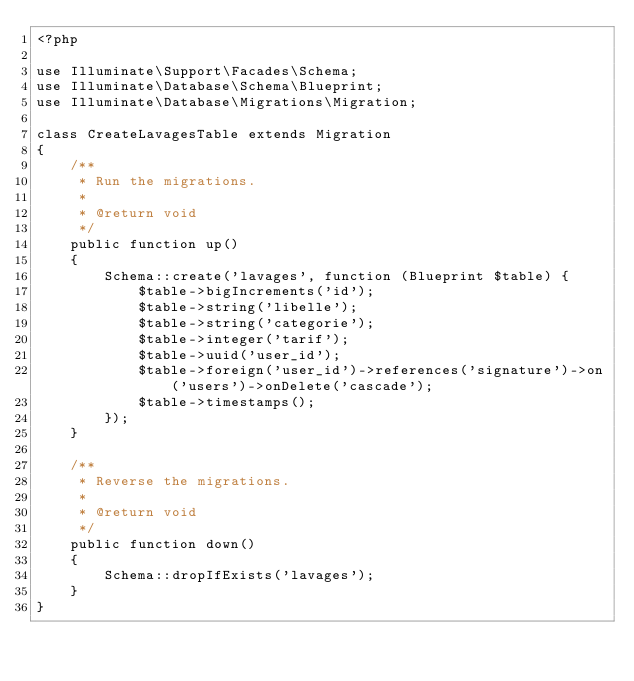<code> <loc_0><loc_0><loc_500><loc_500><_PHP_><?php

use Illuminate\Support\Facades\Schema;
use Illuminate\Database\Schema\Blueprint;
use Illuminate\Database\Migrations\Migration;

class CreateLavagesTable extends Migration
{
    /**
     * Run the migrations.
     *
     * @return void
     */
    public function up()
    {
        Schema::create('lavages', function (Blueprint $table) {
            $table->bigIncrements('id');
            $table->string('libelle');
            $table->string('categorie');
            $table->integer('tarif');
            $table->uuid('user_id');
            $table->foreign('user_id')->references('signature')->on('users')->onDelete('cascade');
            $table->timestamps();
        });
    }

    /**
     * Reverse the migrations.
     *
     * @return void
     */
    public function down()
    {
        Schema::dropIfExists('lavages');
    }
}
</code> 